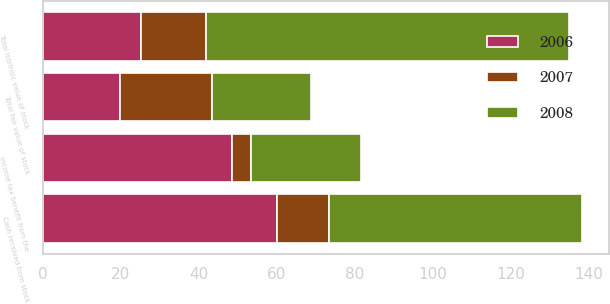<chart> <loc_0><loc_0><loc_500><loc_500><stacked_bar_chart><ecel><fcel>Total intrinsic value of stock<fcel>Cash received from stock<fcel>Income tax benefit from the<fcel>Total fair value of stock<nl><fcel>2007<fcel>16.6<fcel>13.2<fcel>4.8<fcel>23.7<nl><fcel>2008<fcel>93.1<fcel>64.9<fcel>28.4<fcel>25.2<nl><fcel>2006<fcel>25.2<fcel>60.1<fcel>48.5<fcel>19.8<nl></chart> 